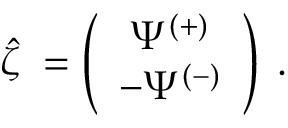<formula> <loc_0><loc_0><loc_500><loc_500>\hat { \zeta } { \Psi } = \left ( \begin{array} { c } { { \Psi ^ { ( + ) } } } \\ { { - \Psi ^ { ( - ) } } } \end{array} \right ) \, .</formula> 